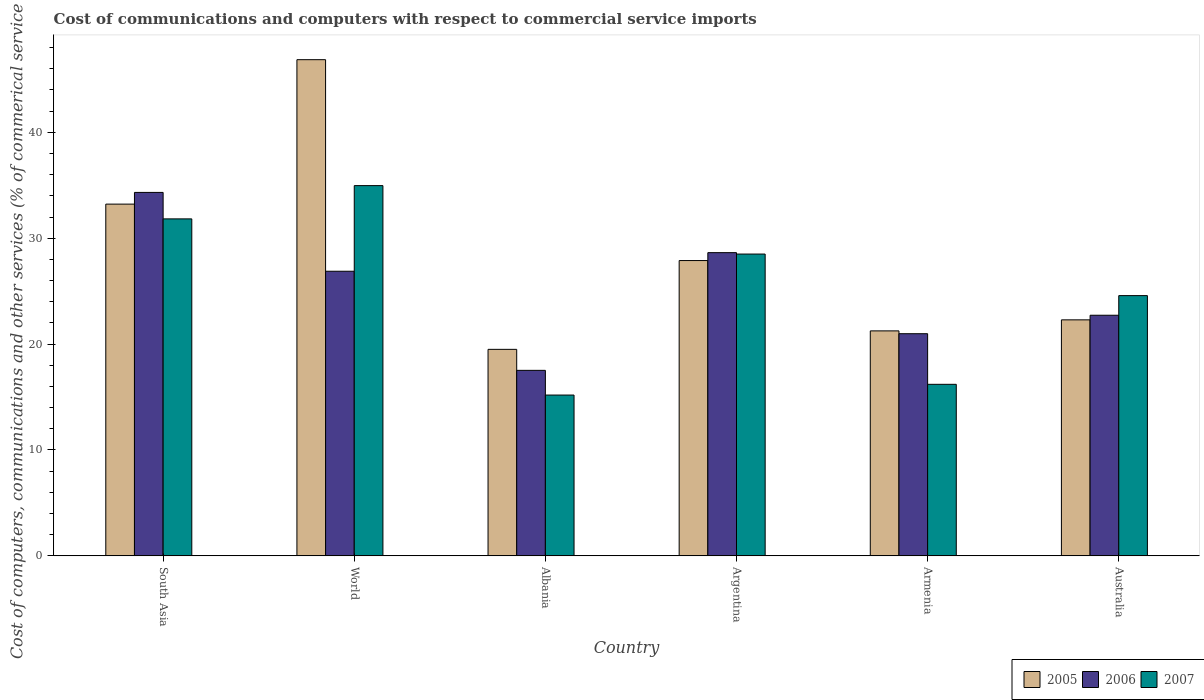How many groups of bars are there?
Make the answer very short. 6. What is the label of the 4th group of bars from the left?
Provide a short and direct response. Argentina. What is the cost of communications and computers in 2007 in South Asia?
Provide a succinct answer. 31.83. Across all countries, what is the maximum cost of communications and computers in 2005?
Provide a short and direct response. 46.86. Across all countries, what is the minimum cost of communications and computers in 2005?
Keep it short and to the point. 19.5. In which country was the cost of communications and computers in 2005 maximum?
Keep it short and to the point. World. In which country was the cost of communications and computers in 2007 minimum?
Provide a succinct answer. Albania. What is the total cost of communications and computers in 2006 in the graph?
Your answer should be compact. 151.07. What is the difference between the cost of communications and computers in 2005 in Argentina and that in South Asia?
Provide a succinct answer. -5.33. What is the difference between the cost of communications and computers in 2005 in World and the cost of communications and computers in 2007 in Australia?
Offer a very short reply. 22.28. What is the average cost of communications and computers in 2005 per country?
Your response must be concise. 28.5. What is the difference between the cost of communications and computers of/in 2005 and cost of communications and computers of/in 2007 in Armenia?
Keep it short and to the point. 5.05. What is the ratio of the cost of communications and computers in 2007 in Armenia to that in World?
Keep it short and to the point. 0.46. Is the difference between the cost of communications and computers in 2005 in Argentina and Armenia greater than the difference between the cost of communications and computers in 2007 in Argentina and Armenia?
Provide a short and direct response. No. What is the difference between the highest and the second highest cost of communications and computers in 2007?
Provide a succinct answer. 6.46. What is the difference between the highest and the lowest cost of communications and computers in 2007?
Offer a very short reply. 19.78. What does the 1st bar from the left in South Asia represents?
Make the answer very short. 2005. How many countries are there in the graph?
Give a very brief answer. 6. Where does the legend appear in the graph?
Make the answer very short. Bottom right. How many legend labels are there?
Give a very brief answer. 3. What is the title of the graph?
Ensure brevity in your answer.  Cost of communications and computers with respect to commercial service imports. What is the label or title of the X-axis?
Your answer should be very brief. Country. What is the label or title of the Y-axis?
Give a very brief answer. Cost of computers, communications and other services (% of commerical service exports). What is the Cost of computers, communications and other services (% of commerical service exports) of 2005 in South Asia?
Your response must be concise. 33.22. What is the Cost of computers, communications and other services (% of commerical service exports) in 2006 in South Asia?
Give a very brief answer. 34.33. What is the Cost of computers, communications and other services (% of commerical service exports) in 2007 in South Asia?
Your answer should be compact. 31.83. What is the Cost of computers, communications and other services (% of commerical service exports) of 2005 in World?
Provide a short and direct response. 46.86. What is the Cost of computers, communications and other services (% of commerical service exports) of 2006 in World?
Give a very brief answer. 26.88. What is the Cost of computers, communications and other services (% of commerical service exports) of 2007 in World?
Offer a very short reply. 34.97. What is the Cost of computers, communications and other services (% of commerical service exports) of 2005 in Albania?
Provide a succinct answer. 19.5. What is the Cost of computers, communications and other services (% of commerical service exports) in 2006 in Albania?
Make the answer very short. 17.52. What is the Cost of computers, communications and other services (% of commerical service exports) of 2007 in Albania?
Offer a terse response. 15.19. What is the Cost of computers, communications and other services (% of commerical service exports) in 2005 in Argentina?
Offer a very short reply. 27.89. What is the Cost of computers, communications and other services (% of commerical service exports) of 2006 in Argentina?
Provide a succinct answer. 28.64. What is the Cost of computers, communications and other services (% of commerical service exports) of 2007 in Argentina?
Ensure brevity in your answer.  28.5. What is the Cost of computers, communications and other services (% of commerical service exports) of 2005 in Armenia?
Give a very brief answer. 21.25. What is the Cost of computers, communications and other services (% of commerical service exports) of 2006 in Armenia?
Offer a terse response. 20.98. What is the Cost of computers, communications and other services (% of commerical service exports) of 2007 in Armenia?
Provide a short and direct response. 16.2. What is the Cost of computers, communications and other services (% of commerical service exports) in 2005 in Australia?
Your response must be concise. 22.29. What is the Cost of computers, communications and other services (% of commerical service exports) in 2006 in Australia?
Provide a short and direct response. 22.72. What is the Cost of computers, communications and other services (% of commerical service exports) in 2007 in Australia?
Provide a short and direct response. 24.58. Across all countries, what is the maximum Cost of computers, communications and other services (% of commerical service exports) in 2005?
Keep it short and to the point. 46.86. Across all countries, what is the maximum Cost of computers, communications and other services (% of commerical service exports) of 2006?
Give a very brief answer. 34.33. Across all countries, what is the maximum Cost of computers, communications and other services (% of commerical service exports) of 2007?
Keep it short and to the point. 34.97. Across all countries, what is the minimum Cost of computers, communications and other services (% of commerical service exports) in 2005?
Offer a very short reply. 19.5. Across all countries, what is the minimum Cost of computers, communications and other services (% of commerical service exports) in 2006?
Your answer should be compact. 17.52. Across all countries, what is the minimum Cost of computers, communications and other services (% of commerical service exports) of 2007?
Your answer should be compact. 15.19. What is the total Cost of computers, communications and other services (% of commerical service exports) of 2005 in the graph?
Keep it short and to the point. 171.01. What is the total Cost of computers, communications and other services (% of commerical service exports) of 2006 in the graph?
Ensure brevity in your answer.  151.07. What is the total Cost of computers, communications and other services (% of commerical service exports) in 2007 in the graph?
Your response must be concise. 151.26. What is the difference between the Cost of computers, communications and other services (% of commerical service exports) in 2005 in South Asia and that in World?
Your answer should be very brief. -13.64. What is the difference between the Cost of computers, communications and other services (% of commerical service exports) of 2006 in South Asia and that in World?
Offer a very short reply. 7.45. What is the difference between the Cost of computers, communications and other services (% of commerical service exports) in 2007 in South Asia and that in World?
Ensure brevity in your answer.  -3.14. What is the difference between the Cost of computers, communications and other services (% of commerical service exports) of 2005 in South Asia and that in Albania?
Make the answer very short. 13.72. What is the difference between the Cost of computers, communications and other services (% of commerical service exports) of 2006 in South Asia and that in Albania?
Your response must be concise. 16.81. What is the difference between the Cost of computers, communications and other services (% of commerical service exports) in 2007 in South Asia and that in Albania?
Offer a terse response. 16.64. What is the difference between the Cost of computers, communications and other services (% of commerical service exports) of 2005 in South Asia and that in Argentina?
Provide a short and direct response. 5.33. What is the difference between the Cost of computers, communications and other services (% of commerical service exports) in 2006 in South Asia and that in Argentina?
Your answer should be compact. 5.69. What is the difference between the Cost of computers, communications and other services (% of commerical service exports) in 2007 in South Asia and that in Argentina?
Give a very brief answer. 3.32. What is the difference between the Cost of computers, communications and other services (% of commerical service exports) of 2005 in South Asia and that in Armenia?
Your answer should be very brief. 11.97. What is the difference between the Cost of computers, communications and other services (% of commerical service exports) in 2006 in South Asia and that in Armenia?
Keep it short and to the point. 13.34. What is the difference between the Cost of computers, communications and other services (% of commerical service exports) in 2007 in South Asia and that in Armenia?
Your answer should be compact. 15.63. What is the difference between the Cost of computers, communications and other services (% of commerical service exports) in 2005 in South Asia and that in Australia?
Provide a short and direct response. 10.93. What is the difference between the Cost of computers, communications and other services (% of commerical service exports) of 2006 in South Asia and that in Australia?
Provide a short and direct response. 11.6. What is the difference between the Cost of computers, communications and other services (% of commerical service exports) of 2007 in South Asia and that in Australia?
Your response must be concise. 7.25. What is the difference between the Cost of computers, communications and other services (% of commerical service exports) of 2005 in World and that in Albania?
Make the answer very short. 27.36. What is the difference between the Cost of computers, communications and other services (% of commerical service exports) of 2006 in World and that in Albania?
Make the answer very short. 9.36. What is the difference between the Cost of computers, communications and other services (% of commerical service exports) in 2007 in World and that in Albania?
Give a very brief answer. 19.78. What is the difference between the Cost of computers, communications and other services (% of commerical service exports) of 2005 in World and that in Argentina?
Your answer should be compact. 18.97. What is the difference between the Cost of computers, communications and other services (% of commerical service exports) of 2006 in World and that in Argentina?
Keep it short and to the point. -1.76. What is the difference between the Cost of computers, communications and other services (% of commerical service exports) in 2007 in World and that in Argentina?
Give a very brief answer. 6.46. What is the difference between the Cost of computers, communications and other services (% of commerical service exports) of 2005 in World and that in Armenia?
Offer a very short reply. 25.61. What is the difference between the Cost of computers, communications and other services (% of commerical service exports) in 2006 in World and that in Armenia?
Make the answer very short. 5.9. What is the difference between the Cost of computers, communications and other services (% of commerical service exports) of 2007 in World and that in Armenia?
Keep it short and to the point. 18.77. What is the difference between the Cost of computers, communications and other services (% of commerical service exports) in 2005 in World and that in Australia?
Offer a terse response. 24.57. What is the difference between the Cost of computers, communications and other services (% of commerical service exports) of 2006 in World and that in Australia?
Make the answer very short. 4.16. What is the difference between the Cost of computers, communications and other services (% of commerical service exports) in 2007 in World and that in Australia?
Your response must be concise. 10.39. What is the difference between the Cost of computers, communications and other services (% of commerical service exports) of 2005 in Albania and that in Argentina?
Provide a succinct answer. -8.39. What is the difference between the Cost of computers, communications and other services (% of commerical service exports) in 2006 in Albania and that in Argentina?
Make the answer very short. -11.12. What is the difference between the Cost of computers, communications and other services (% of commerical service exports) in 2007 in Albania and that in Argentina?
Provide a succinct answer. -13.32. What is the difference between the Cost of computers, communications and other services (% of commerical service exports) of 2005 in Albania and that in Armenia?
Give a very brief answer. -1.74. What is the difference between the Cost of computers, communications and other services (% of commerical service exports) in 2006 in Albania and that in Armenia?
Provide a succinct answer. -3.46. What is the difference between the Cost of computers, communications and other services (% of commerical service exports) of 2007 in Albania and that in Armenia?
Ensure brevity in your answer.  -1.01. What is the difference between the Cost of computers, communications and other services (% of commerical service exports) in 2005 in Albania and that in Australia?
Provide a succinct answer. -2.79. What is the difference between the Cost of computers, communications and other services (% of commerical service exports) in 2006 in Albania and that in Australia?
Keep it short and to the point. -5.2. What is the difference between the Cost of computers, communications and other services (% of commerical service exports) in 2007 in Albania and that in Australia?
Offer a terse response. -9.39. What is the difference between the Cost of computers, communications and other services (% of commerical service exports) in 2005 in Argentina and that in Armenia?
Offer a very short reply. 6.64. What is the difference between the Cost of computers, communications and other services (% of commerical service exports) of 2006 in Argentina and that in Armenia?
Ensure brevity in your answer.  7.66. What is the difference between the Cost of computers, communications and other services (% of commerical service exports) of 2007 in Argentina and that in Armenia?
Your response must be concise. 12.3. What is the difference between the Cost of computers, communications and other services (% of commerical service exports) in 2005 in Argentina and that in Australia?
Make the answer very short. 5.6. What is the difference between the Cost of computers, communications and other services (% of commerical service exports) of 2006 in Argentina and that in Australia?
Offer a very short reply. 5.91. What is the difference between the Cost of computers, communications and other services (% of commerical service exports) of 2007 in Argentina and that in Australia?
Make the answer very short. 3.93. What is the difference between the Cost of computers, communications and other services (% of commerical service exports) in 2005 in Armenia and that in Australia?
Make the answer very short. -1.04. What is the difference between the Cost of computers, communications and other services (% of commerical service exports) in 2006 in Armenia and that in Australia?
Provide a succinct answer. -1.74. What is the difference between the Cost of computers, communications and other services (% of commerical service exports) in 2007 in Armenia and that in Australia?
Ensure brevity in your answer.  -8.38. What is the difference between the Cost of computers, communications and other services (% of commerical service exports) in 2005 in South Asia and the Cost of computers, communications and other services (% of commerical service exports) in 2006 in World?
Your answer should be compact. 6.34. What is the difference between the Cost of computers, communications and other services (% of commerical service exports) of 2005 in South Asia and the Cost of computers, communications and other services (% of commerical service exports) of 2007 in World?
Your response must be concise. -1.75. What is the difference between the Cost of computers, communications and other services (% of commerical service exports) in 2006 in South Asia and the Cost of computers, communications and other services (% of commerical service exports) in 2007 in World?
Your answer should be very brief. -0.64. What is the difference between the Cost of computers, communications and other services (% of commerical service exports) in 2005 in South Asia and the Cost of computers, communications and other services (% of commerical service exports) in 2006 in Albania?
Offer a very short reply. 15.7. What is the difference between the Cost of computers, communications and other services (% of commerical service exports) in 2005 in South Asia and the Cost of computers, communications and other services (% of commerical service exports) in 2007 in Albania?
Your answer should be very brief. 18.03. What is the difference between the Cost of computers, communications and other services (% of commerical service exports) in 2006 in South Asia and the Cost of computers, communications and other services (% of commerical service exports) in 2007 in Albania?
Your answer should be compact. 19.14. What is the difference between the Cost of computers, communications and other services (% of commerical service exports) in 2005 in South Asia and the Cost of computers, communications and other services (% of commerical service exports) in 2006 in Argentina?
Your response must be concise. 4.58. What is the difference between the Cost of computers, communications and other services (% of commerical service exports) of 2005 in South Asia and the Cost of computers, communications and other services (% of commerical service exports) of 2007 in Argentina?
Provide a short and direct response. 4.72. What is the difference between the Cost of computers, communications and other services (% of commerical service exports) of 2006 in South Asia and the Cost of computers, communications and other services (% of commerical service exports) of 2007 in Argentina?
Your response must be concise. 5.82. What is the difference between the Cost of computers, communications and other services (% of commerical service exports) of 2005 in South Asia and the Cost of computers, communications and other services (% of commerical service exports) of 2006 in Armenia?
Offer a very short reply. 12.24. What is the difference between the Cost of computers, communications and other services (% of commerical service exports) in 2005 in South Asia and the Cost of computers, communications and other services (% of commerical service exports) in 2007 in Armenia?
Ensure brevity in your answer.  17.02. What is the difference between the Cost of computers, communications and other services (% of commerical service exports) in 2006 in South Asia and the Cost of computers, communications and other services (% of commerical service exports) in 2007 in Armenia?
Your response must be concise. 18.12. What is the difference between the Cost of computers, communications and other services (% of commerical service exports) of 2005 in South Asia and the Cost of computers, communications and other services (% of commerical service exports) of 2006 in Australia?
Make the answer very short. 10.5. What is the difference between the Cost of computers, communications and other services (% of commerical service exports) in 2005 in South Asia and the Cost of computers, communications and other services (% of commerical service exports) in 2007 in Australia?
Provide a succinct answer. 8.64. What is the difference between the Cost of computers, communications and other services (% of commerical service exports) in 2006 in South Asia and the Cost of computers, communications and other services (% of commerical service exports) in 2007 in Australia?
Your answer should be very brief. 9.75. What is the difference between the Cost of computers, communications and other services (% of commerical service exports) in 2005 in World and the Cost of computers, communications and other services (% of commerical service exports) in 2006 in Albania?
Your response must be concise. 29.34. What is the difference between the Cost of computers, communications and other services (% of commerical service exports) in 2005 in World and the Cost of computers, communications and other services (% of commerical service exports) in 2007 in Albania?
Your answer should be very brief. 31.68. What is the difference between the Cost of computers, communications and other services (% of commerical service exports) in 2006 in World and the Cost of computers, communications and other services (% of commerical service exports) in 2007 in Albania?
Offer a terse response. 11.69. What is the difference between the Cost of computers, communications and other services (% of commerical service exports) of 2005 in World and the Cost of computers, communications and other services (% of commerical service exports) of 2006 in Argentina?
Your answer should be compact. 18.23. What is the difference between the Cost of computers, communications and other services (% of commerical service exports) of 2005 in World and the Cost of computers, communications and other services (% of commerical service exports) of 2007 in Argentina?
Ensure brevity in your answer.  18.36. What is the difference between the Cost of computers, communications and other services (% of commerical service exports) of 2006 in World and the Cost of computers, communications and other services (% of commerical service exports) of 2007 in Argentina?
Your answer should be very brief. -1.62. What is the difference between the Cost of computers, communications and other services (% of commerical service exports) of 2005 in World and the Cost of computers, communications and other services (% of commerical service exports) of 2006 in Armenia?
Keep it short and to the point. 25.88. What is the difference between the Cost of computers, communications and other services (% of commerical service exports) of 2005 in World and the Cost of computers, communications and other services (% of commerical service exports) of 2007 in Armenia?
Ensure brevity in your answer.  30.66. What is the difference between the Cost of computers, communications and other services (% of commerical service exports) in 2006 in World and the Cost of computers, communications and other services (% of commerical service exports) in 2007 in Armenia?
Provide a short and direct response. 10.68. What is the difference between the Cost of computers, communications and other services (% of commerical service exports) in 2005 in World and the Cost of computers, communications and other services (% of commerical service exports) in 2006 in Australia?
Offer a very short reply. 24.14. What is the difference between the Cost of computers, communications and other services (% of commerical service exports) of 2005 in World and the Cost of computers, communications and other services (% of commerical service exports) of 2007 in Australia?
Provide a short and direct response. 22.28. What is the difference between the Cost of computers, communications and other services (% of commerical service exports) of 2006 in World and the Cost of computers, communications and other services (% of commerical service exports) of 2007 in Australia?
Ensure brevity in your answer.  2.3. What is the difference between the Cost of computers, communications and other services (% of commerical service exports) in 2005 in Albania and the Cost of computers, communications and other services (% of commerical service exports) in 2006 in Argentina?
Your answer should be very brief. -9.13. What is the difference between the Cost of computers, communications and other services (% of commerical service exports) of 2005 in Albania and the Cost of computers, communications and other services (% of commerical service exports) of 2007 in Argentina?
Ensure brevity in your answer.  -9. What is the difference between the Cost of computers, communications and other services (% of commerical service exports) of 2006 in Albania and the Cost of computers, communications and other services (% of commerical service exports) of 2007 in Argentina?
Give a very brief answer. -10.98. What is the difference between the Cost of computers, communications and other services (% of commerical service exports) in 2005 in Albania and the Cost of computers, communications and other services (% of commerical service exports) in 2006 in Armenia?
Your answer should be very brief. -1.48. What is the difference between the Cost of computers, communications and other services (% of commerical service exports) of 2005 in Albania and the Cost of computers, communications and other services (% of commerical service exports) of 2007 in Armenia?
Your answer should be very brief. 3.3. What is the difference between the Cost of computers, communications and other services (% of commerical service exports) of 2006 in Albania and the Cost of computers, communications and other services (% of commerical service exports) of 2007 in Armenia?
Keep it short and to the point. 1.32. What is the difference between the Cost of computers, communications and other services (% of commerical service exports) in 2005 in Albania and the Cost of computers, communications and other services (% of commerical service exports) in 2006 in Australia?
Provide a short and direct response. -3.22. What is the difference between the Cost of computers, communications and other services (% of commerical service exports) of 2005 in Albania and the Cost of computers, communications and other services (% of commerical service exports) of 2007 in Australia?
Provide a short and direct response. -5.07. What is the difference between the Cost of computers, communications and other services (% of commerical service exports) in 2006 in Albania and the Cost of computers, communications and other services (% of commerical service exports) in 2007 in Australia?
Ensure brevity in your answer.  -7.06. What is the difference between the Cost of computers, communications and other services (% of commerical service exports) in 2005 in Argentina and the Cost of computers, communications and other services (% of commerical service exports) in 2006 in Armenia?
Offer a very short reply. 6.91. What is the difference between the Cost of computers, communications and other services (% of commerical service exports) in 2005 in Argentina and the Cost of computers, communications and other services (% of commerical service exports) in 2007 in Armenia?
Offer a very short reply. 11.69. What is the difference between the Cost of computers, communications and other services (% of commerical service exports) of 2006 in Argentina and the Cost of computers, communications and other services (% of commerical service exports) of 2007 in Armenia?
Make the answer very short. 12.44. What is the difference between the Cost of computers, communications and other services (% of commerical service exports) in 2005 in Argentina and the Cost of computers, communications and other services (% of commerical service exports) in 2006 in Australia?
Give a very brief answer. 5.16. What is the difference between the Cost of computers, communications and other services (% of commerical service exports) in 2005 in Argentina and the Cost of computers, communications and other services (% of commerical service exports) in 2007 in Australia?
Make the answer very short. 3.31. What is the difference between the Cost of computers, communications and other services (% of commerical service exports) in 2006 in Argentina and the Cost of computers, communications and other services (% of commerical service exports) in 2007 in Australia?
Provide a short and direct response. 4.06. What is the difference between the Cost of computers, communications and other services (% of commerical service exports) of 2005 in Armenia and the Cost of computers, communications and other services (% of commerical service exports) of 2006 in Australia?
Offer a terse response. -1.48. What is the difference between the Cost of computers, communications and other services (% of commerical service exports) in 2005 in Armenia and the Cost of computers, communications and other services (% of commerical service exports) in 2007 in Australia?
Offer a very short reply. -3.33. What is the difference between the Cost of computers, communications and other services (% of commerical service exports) of 2006 in Armenia and the Cost of computers, communications and other services (% of commerical service exports) of 2007 in Australia?
Provide a short and direct response. -3.6. What is the average Cost of computers, communications and other services (% of commerical service exports) in 2005 per country?
Provide a short and direct response. 28.5. What is the average Cost of computers, communications and other services (% of commerical service exports) of 2006 per country?
Make the answer very short. 25.18. What is the average Cost of computers, communications and other services (% of commerical service exports) in 2007 per country?
Your answer should be very brief. 25.21. What is the difference between the Cost of computers, communications and other services (% of commerical service exports) of 2005 and Cost of computers, communications and other services (% of commerical service exports) of 2006 in South Asia?
Provide a short and direct response. -1.1. What is the difference between the Cost of computers, communications and other services (% of commerical service exports) in 2005 and Cost of computers, communications and other services (% of commerical service exports) in 2007 in South Asia?
Offer a terse response. 1.39. What is the difference between the Cost of computers, communications and other services (% of commerical service exports) of 2006 and Cost of computers, communications and other services (% of commerical service exports) of 2007 in South Asia?
Keep it short and to the point. 2.5. What is the difference between the Cost of computers, communications and other services (% of commerical service exports) in 2005 and Cost of computers, communications and other services (% of commerical service exports) in 2006 in World?
Ensure brevity in your answer.  19.98. What is the difference between the Cost of computers, communications and other services (% of commerical service exports) of 2005 and Cost of computers, communications and other services (% of commerical service exports) of 2007 in World?
Ensure brevity in your answer.  11.89. What is the difference between the Cost of computers, communications and other services (% of commerical service exports) of 2006 and Cost of computers, communications and other services (% of commerical service exports) of 2007 in World?
Provide a succinct answer. -8.09. What is the difference between the Cost of computers, communications and other services (% of commerical service exports) in 2005 and Cost of computers, communications and other services (% of commerical service exports) in 2006 in Albania?
Your response must be concise. 1.98. What is the difference between the Cost of computers, communications and other services (% of commerical service exports) of 2005 and Cost of computers, communications and other services (% of commerical service exports) of 2007 in Albania?
Provide a short and direct response. 4.32. What is the difference between the Cost of computers, communications and other services (% of commerical service exports) of 2006 and Cost of computers, communications and other services (% of commerical service exports) of 2007 in Albania?
Give a very brief answer. 2.33. What is the difference between the Cost of computers, communications and other services (% of commerical service exports) of 2005 and Cost of computers, communications and other services (% of commerical service exports) of 2006 in Argentina?
Your answer should be compact. -0.75. What is the difference between the Cost of computers, communications and other services (% of commerical service exports) of 2005 and Cost of computers, communications and other services (% of commerical service exports) of 2007 in Argentina?
Offer a terse response. -0.61. What is the difference between the Cost of computers, communications and other services (% of commerical service exports) in 2006 and Cost of computers, communications and other services (% of commerical service exports) in 2007 in Argentina?
Your answer should be very brief. 0.13. What is the difference between the Cost of computers, communications and other services (% of commerical service exports) of 2005 and Cost of computers, communications and other services (% of commerical service exports) of 2006 in Armenia?
Your response must be concise. 0.27. What is the difference between the Cost of computers, communications and other services (% of commerical service exports) in 2005 and Cost of computers, communications and other services (% of commerical service exports) in 2007 in Armenia?
Provide a short and direct response. 5.05. What is the difference between the Cost of computers, communications and other services (% of commerical service exports) in 2006 and Cost of computers, communications and other services (% of commerical service exports) in 2007 in Armenia?
Offer a terse response. 4.78. What is the difference between the Cost of computers, communications and other services (% of commerical service exports) in 2005 and Cost of computers, communications and other services (% of commerical service exports) in 2006 in Australia?
Offer a terse response. -0.44. What is the difference between the Cost of computers, communications and other services (% of commerical service exports) of 2005 and Cost of computers, communications and other services (% of commerical service exports) of 2007 in Australia?
Ensure brevity in your answer.  -2.29. What is the difference between the Cost of computers, communications and other services (% of commerical service exports) of 2006 and Cost of computers, communications and other services (% of commerical service exports) of 2007 in Australia?
Make the answer very short. -1.85. What is the ratio of the Cost of computers, communications and other services (% of commerical service exports) of 2005 in South Asia to that in World?
Make the answer very short. 0.71. What is the ratio of the Cost of computers, communications and other services (% of commerical service exports) in 2006 in South Asia to that in World?
Offer a very short reply. 1.28. What is the ratio of the Cost of computers, communications and other services (% of commerical service exports) of 2007 in South Asia to that in World?
Ensure brevity in your answer.  0.91. What is the ratio of the Cost of computers, communications and other services (% of commerical service exports) in 2005 in South Asia to that in Albania?
Offer a terse response. 1.7. What is the ratio of the Cost of computers, communications and other services (% of commerical service exports) in 2006 in South Asia to that in Albania?
Your answer should be compact. 1.96. What is the ratio of the Cost of computers, communications and other services (% of commerical service exports) in 2007 in South Asia to that in Albania?
Offer a terse response. 2.1. What is the ratio of the Cost of computers, communications and other services (% of commerical service exports) in 2005 in South Asia to that in Argentina?
Offer a very short reply. 1.19. What is the ratio of the Cost of computers, communications and other services (% of commerical service exports) of 2006 in South Asia to that in Argentina?
Your answer should be very brief. 1.2. What is the ratio of the Cost of computers, communications and other services (% of commerical service exports) in 2007 in South Asia to that in Argentina?
Your answer should be compact. 1.12. What is the ratio of the Cost of computers, communications and other services (% of commerical service exports) in 2005 in South Asia to that in Armenia?
Ensure brevity in your answer.  1.56. What is the ratio of the Cost of computers, communications and other services (% of commerical service exports) in 2006 in South Asia to that in Armenia?
Make the answer very short. 1.64. What is the ratio of the Cost of computers, communications and other services (% of commerical service exports) of 2007 in South Asia to that in Armenia?
Your answer should be compact. 1.96. What is the ratio of the Cost of computers, communications and other services (% of commerical service exports) in 2005 in South Asia to that in Australia?
Offer a terse response. 1.49. What is the ratio of the Cost of computers, communications and other services (% of commerical service exports) of 2006 in South Asia to that in Australia?
Give a very brief answer. 1.51. What is the ratio of the Cost of computers, communications and other services (% of commerical service exports) of 2007 in South Asia to that in Australia?
Ensure brevity in your answer.  1.29. What is the ratio of the Cost of computers, communications and other services (% of commerical service exports) of 2005 in World to that in Albania?
Give a very brief answer. 2.4. What is the ratio of the Cost of computers, communications and other services (% of commerical service exports) of 2006 in World to that in Albania?
Your answer should be very brief. 1.53. What is the ratio of the Cost of computers, communications and other services (% of commerical service exports) in 2007 in World to that in Albania?
Make the answer very short. 2.3. What is the ratio of the Cost of computers, communications and other services (% of commerical service exports) of 2005 in World to that in Argentina?
Keep it short and to the point. 1.68. What is the ratio of the Cost of computers, communications and other services (% of commerical service exports) of 2006 in World to that in Argentina?
Ensure brevity in your answer.  0.94. What is the ratio of the Cost of computers, communications and other services (% of commerical service exports) of 2007 in World to that in Argentina?
Provide a succinct answer. 1.23. What is the ratio of the Cost of computers, communications and other services (% of commerical service exports) in 2005 in World to that in Armenia?
Offer a very short reply. 2.21. What is the ratio of the Cost of computers, communications and other services (% of commerical service exports) of 2006 in World to that in Armenia?
Your answer should be very brief. 1.28. What is the ratio of the Cost of computers, communications and other services (% of commerical service exports) of 2007 in World to that in Armenia?
Ensure brevity in your answer.  2.16. What is the ratio of the Cost of computers, communications and other services (% of commerical service exports) in 2005 in World to that in Australia?
Ensure brevity in your answer.  2.1. What is the ratio of the Cost of computers, communications and other services (% of commerical service exports) in 2006 in World to that in Australia?
Keep it short and to the point. 1.18. What is the ratio of the Cost of computers, communications and other services (% of commerical service exports) of 2007 in World to that in Australia?
Provide a succinct answer. 1.42. What is the ratio of the Cost of computers, communications and other services (% of commerical service exports) in 2005 in Albania to that in Argentina?
Provide a succinct answer. 0.7. What is the ratio of the Cost of computers, communications and other services (% of commerical service exports) of 2006 in Albania to that in Argentina?
Your response must be concise. 0.61. What is the ratio of the Cost of computers, communications and other services (% of commerical service exports) of 2007 in Albania to that in Argentina?
Ensure brevity in your answer.  0.53. What is the ratio of the Cost of computers, communications and other services (% of commerical service exports) in 2005 in Albania to that in Armenia?
Provide a short and direct response. 0.92. What is the ratio of the Cost of computers, communications and other services (% of commerical service exports) in 2006 in Albania to that in Armenia?
Provide a short and direct response. 0.84. What is the ratio of the Cost of computers, communications and other services (% of commerical service exports) in 2007 in Albania to that in Armenia?
Your answer should be very brief. 0.94. What is the ratio of the Cost of computers, communications and other services (% of commerical service exports) in 2005 in Albania to that in Australia?
Your answer should be very brief. 0.88. What is the ratio of the Cost of computers, communications and other services (% of commerical service exports) of 2006 in Albania to that in Australia?
Offer a terse response. 0.77. What is the ratio of the Cost of computers, communications and other services (% of commerical service exports) of 2007 in Albania to that in Australia?
Your answer should be very brief. 0.62. What is the ratio of the Cost of computers, communications and other services (% of commerical service exports) of 2005 in Argentina to that in Armenia?
Give a very brief answer. 1.31. What is the ratio of the Cost of computers, communications and other services (% of commerical service exports) in 2006 in Argentina to that in Armenia?
Ensure brevity in your answer.  1.36. What is the ratio of the Cost of computers, communications and other services (% of commerical service exports) in 2007 in Argentina to that in Armenia?
Provide a succinct answer. 1.76. What is the ratio of the Cost of computers, communications and other services (% of commerical service exports) of 2005 in Argentina to that in Australia?
Your answer should be compact. 1.25. What is the ratio of the Cost of computers, communications and other services (% of commerical service exports) of 2006 in Argentina to that in Australia?
Provide a succinct answer. 1.26. What is the ratio of the Cost of computers, communications and other services (% of commerical service exports) in 2007 in Argentina to that in Australia?
Provide a short and direct response. 1.16. What is the ratio of the Cost of computers, communications and other services (% of commerical service exports) in 2005 in Armenia to that in Australia?
Provide a succinct answer. 0.95. What is the ratio of the Cost of computers, communications and other services (% of commerical service exports) in 2006 in Armenia to that in Australia?
Your response must be concise. 0.92. What is the ratio of the Cost of computers, communications and other services (% of commerical service exports) in 2007 in Armenia to that in Australia?
Provide a short and direct response. 0.66. What is the difference between the highest and the second highest Cost of computers, communications and other services (% of commerical service exports) in 2005?
Make the answer very short. 13.64. What is the difference between the highest and the second highest Cost of computers, communications and other services (% of commerical service exports) in 2006?
Ensure brevity in your answer.  5.69. What is the difference between the highest and the second highest Cost of computers, communications and other services (% of commerical service exports) in 2007?
Ensure brevity in your answer.  3.14. What is the difference between the highest and the lowest Cost of computers, communications and other services (% of commerical service exports) in 2005?
Provide a succinct answer. 27.36. What is the difference between the highest and the lowest Cost of computers, communications and other services (% of commerical service exports) of 2006?
Your answer should be very brief. 16.81. What is the difference between the highest and the lowest Cost of computers, communications and other services (% of commerical service exports) in 2007?
Ensure brevity in your answer.  19.78. 